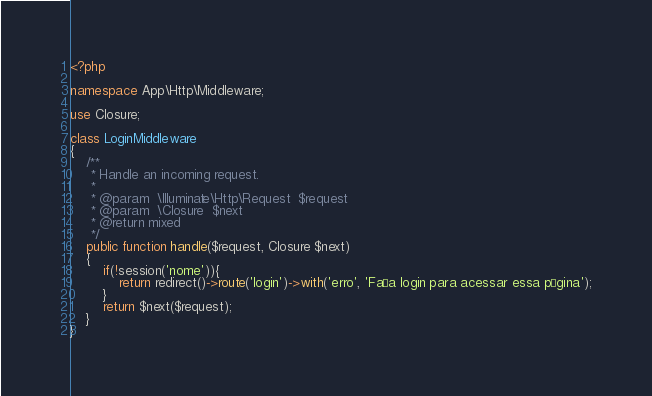<code> <loc_0><loc_0><loc_500><loc_500><_PHP_><?php

namespace App\Http\Middleware;

use Closure;

class LoginMiddleware
{
    /**
     * Handle an incoming request.
     *
     * @param  \Illuminate\Http\Request  $request
     * @param  \Closure  $next
     * @return mixed
     */
    public function handle($request, Closure $next)
    {
        if(!session('nome')){
            return redirect()->route('login')->with('erro', 'Faça login para acessar essa página');
        }
        return $next($request);
    }
}
</code> 